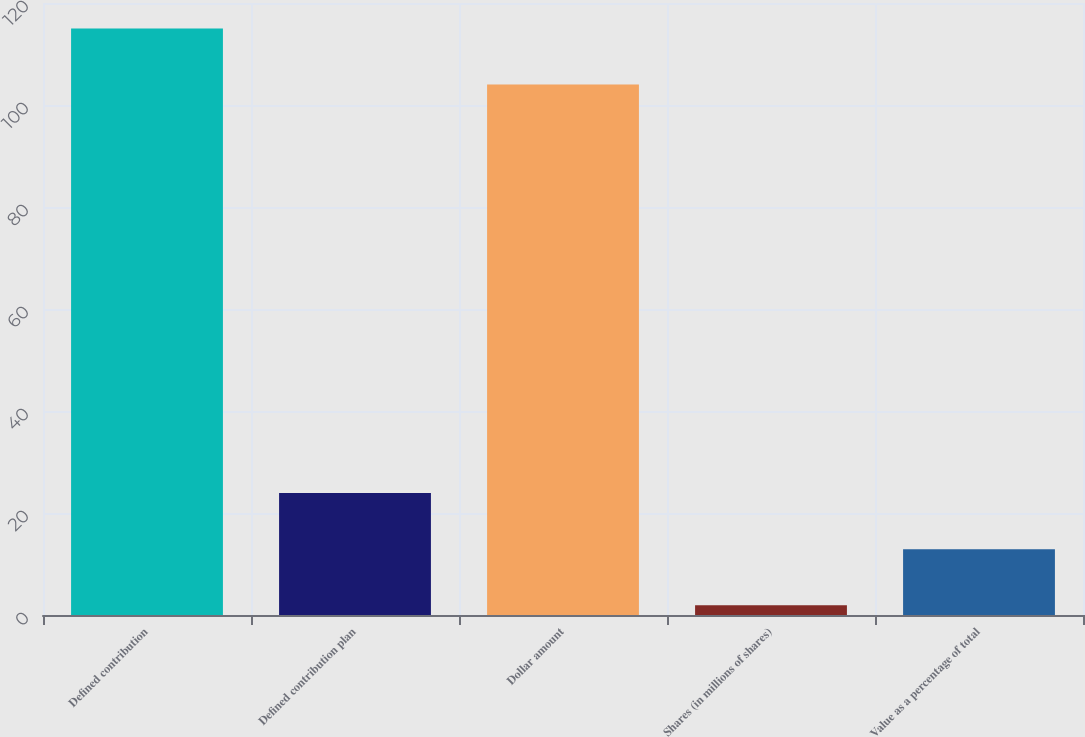Convert chart to OTSL. <chart><loc_0><loc_0><loc_500><loc_500><bar_chart><fcel>Defined contribution<fcel>Defined contribution plan<fcel>Dollar amount<fcel>Shares (in millions of shares)<fcel>Value as a percentage of total<nl><fcel>115.01<fcel>23.92<fcel>104<fcel>1.9<fcel>12.91<nl></chart> 